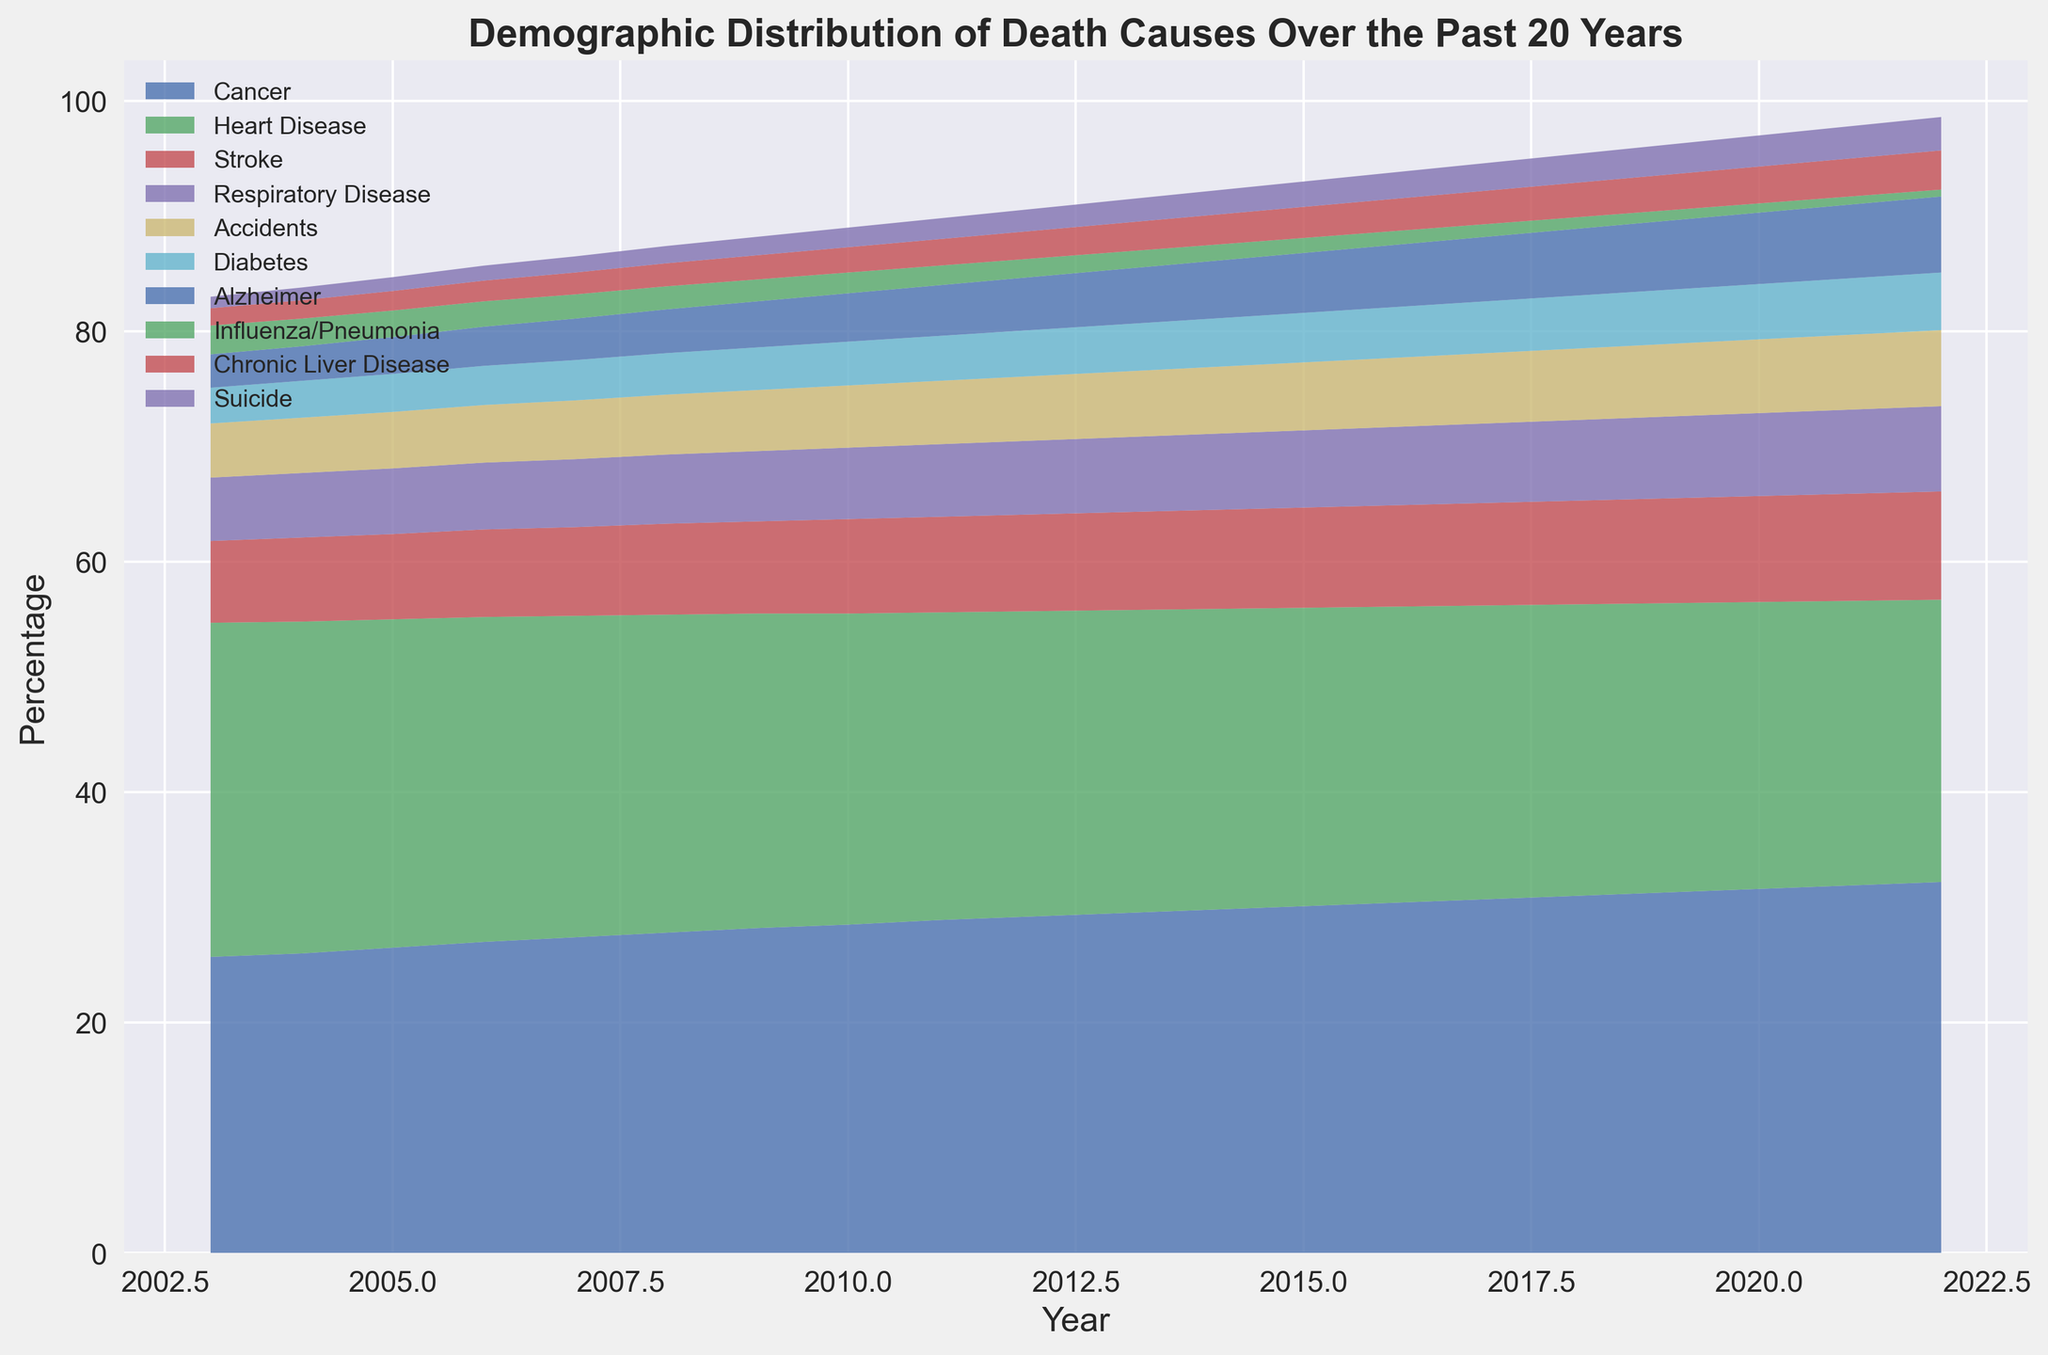What is the general trend of deaths caused by cancer over the past 20 years? By analyzing the figure, we can observe the area representing cancer-related deaths increases steadily over the years, indicating a rising trend.
Answer: Increasing Which cause of death had the second highest percentage in 2022? Examining the figure's stacked areas for 2022, after Cancer, Heart Disease has the next largest area indicating the second highest percentage.
Answer: Heart Disease How has the percentage of deaths caused by Heart Disease changed from 2003 to 2022? By comparing the area of Heart Disease in 2003 to that in 2022, we see it has decreased.
Answer: Decreased Which cause of death shows a consistently increasing trend from 2003 to 2022? Observing the trend lines, Cancer and Alzheimer consistently increase over the years.
Answer: Cancer and Alzheimer What percentage of deaths were caused by Stroke in 2011 and how does that compare to 2003? In 2011, stroke-related deaths account for a larger percentage than in 2003. Comparing the sizes of the areas, Stroke increased from 7.1% in 2003 to 8.3% in 2011.
Answer: Increased from 7.1% to 8.3% What is the visual trend of deaths caused by Influenza/Pneumonia over the years? The area representing Influenza/Pneumonia shrinks over the years on the figure, indicating a decreasing trend.
Answer: Decreasing How does the percentage of Respiratory Disease-related deaths in 2022 compare to that in 2003? Looking at the figure, Respiratory Disease forms a larger area in 2022 compared to 2003, showing an increase from 5.5% to 7.4%.
Answer: Increased from 5.5% to 7.4% In which year did diabetes-related deaths reach 4.5%, and how does that compare to 2003? Referring to the figure, Diabetes-related deaths reach 4.5% in 2017 whereas in 2003 the percentage was 3.1%.
Answer: 2017, increased from 3.1% to 4.5% How does the sum of percentages for Accidents and Chronic Liver Disease in 2022 compare to the year 2003? In 2022, Accidents were 6.6% and Chronic Liver Disease was 3.4%, totaling 10.0%. In 2003, Accidents were 4.7% and Chronic Liver Disease was 1.5%, totaling 6.2%. Comparatively, the sum increased from 6.2% to 10.0%.
Answer: Increased from 6.2% to 10.0% What visual conclusions can you draw about the overall trend in Suicides over the 20-year span? The area for Suicides increases gradually, thus showing an increasing trend over the years.
Answer: Increasing 